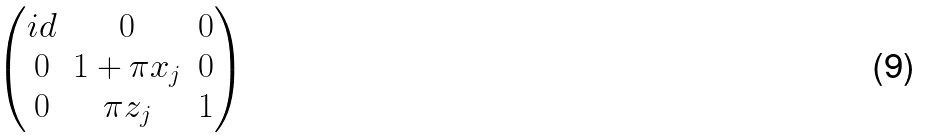<formula> <loc_0><loc_0><loc_500><loc_500>\begin{pmatrix} i d & 0 & 0 \\ 0 & 1 + \pi x _ { j } & 0 \\ 0 & \pi z _ { j } & 1 \end{pmatrix}</formula> 